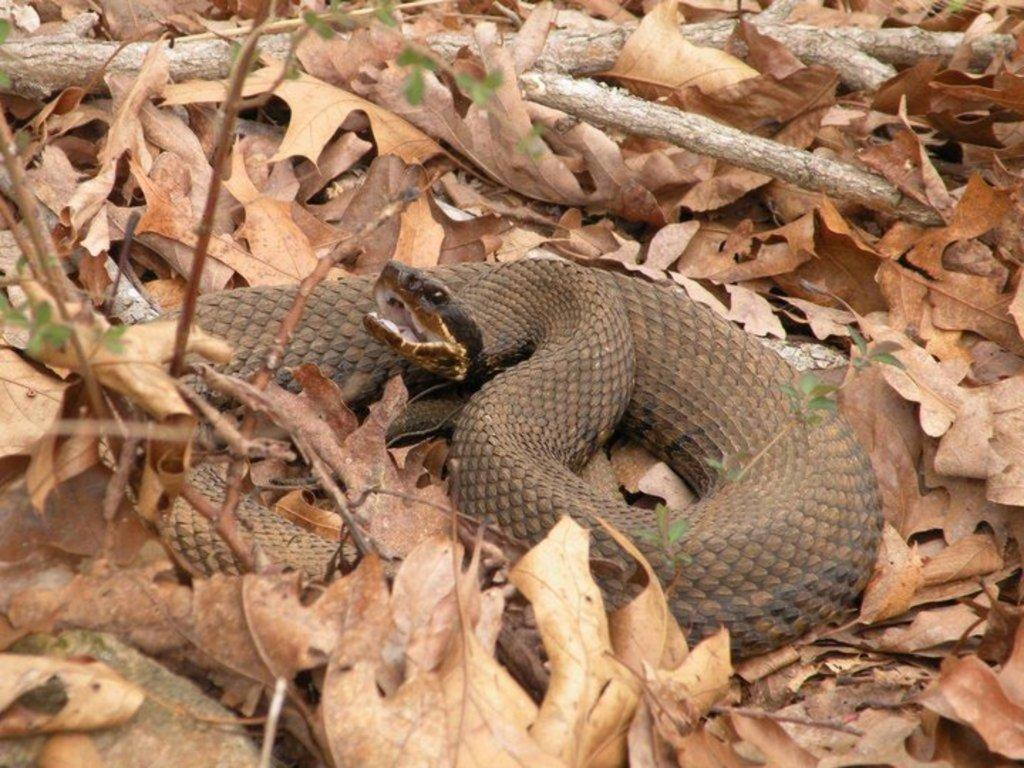What animal is present in the image? There is a snake in the picture. What can be found around the snake in the image? There are dried leaves around the snake. What color is the snake's religion in the image? The snake does not have a religion, and there is no information about the snake's color in the image. 